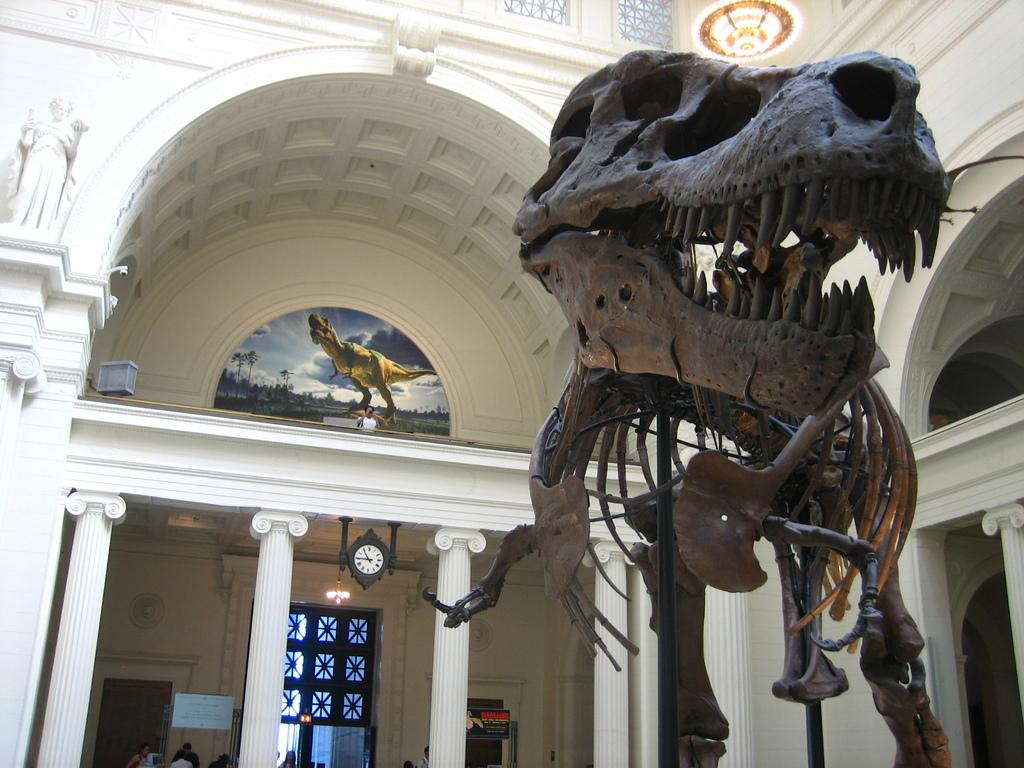What is the main subject of the image? There is a dinosaur skeleton in the image. Where is the dinosaur skeleton located? The dinosaur skeleton is in a museum. What can be observed about the museum's architecture? The museum has white pillars and white walls. What type of marble is being read by the dinosaur in the image? There is no dinosaur present in the image that can read, and there is no marble mentioned in the facts provided. 